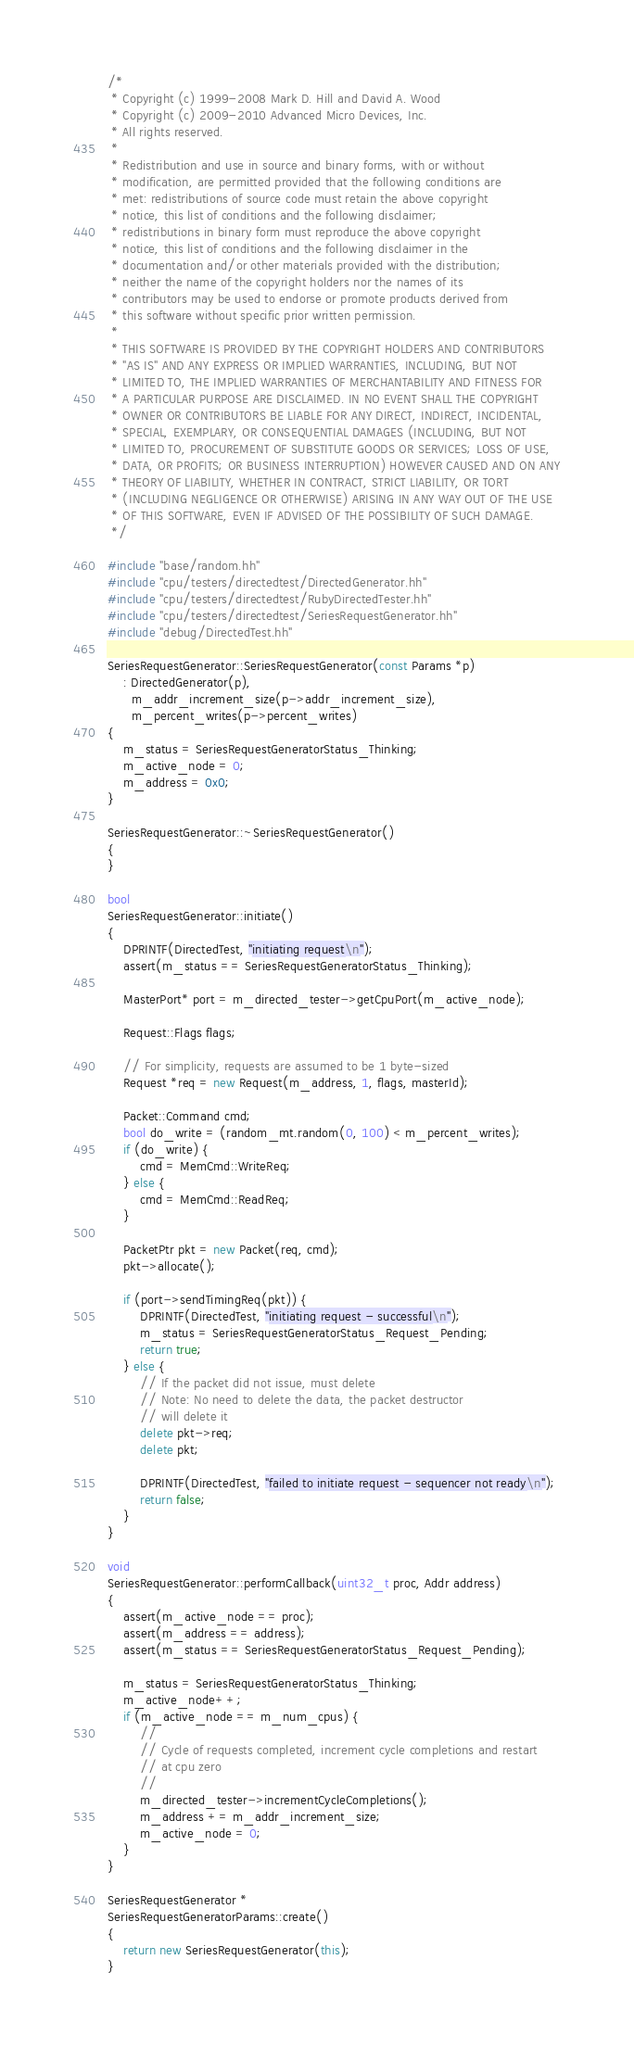<code> <loc_0><loc_0><loc_500><loc_500><_C++_>/*
 * Copyright (c) 1999-2008 Mark D. Hill and David A. Wood
 * Copyright (c) 2009-2010 Advanced Micro Devices, Inc.
 * All rights reserved.
 *
 * Redistribution and use in source and binary forms, with or without
 * modification, are permitted provided that the following conditions are
 * met: redistributions of source code must retain the above copyright
 * notice, this list of conditions and the following disclaimer;
 * redistributions in binary form must reproduce the above copyright
 * notice, this list of conditions and the following disclaimer in the
 * documentation and/or other materials provided with the distribution;
 * neither the name of the copyright holders nor the names of its
 * contributors may be used to endorse or promote products derived from
 * this software without specific prior written permission.
 *
 * THIS SOFTWARE IS PROVIDED BY THE COPYRIGHT HOLDERS AND CONTRIBUTORS
 * "AS IS" AND ANY EXPRESS OR IMPLIED WARRANTIES, INCLUDING, BUT NOT
 * LIMITED TO, THE IMPLIED WARRANTIES OF MERCHANTABILITY AND FITNESS FOR
 * A PARTICULAR PURPOSE ARE DISCLAIMED. IN NO EVENT SHALL THE COPYRIGHT
 * OWNER OR CONTRIBUTORS BE LIABLE FOR ANY DIRECT, INDIRECT, INCIDENTAL,
 * SPECIAL, EXEMPLARY, OR CONSEQUENTIAL DAMAGES (INCLUDING, BUT NOT
 * LIMITED TO, PROCUREMENT OF SUBSTITUTE GOODS OR SERVICES; LOSS OF USE,
 * DATA, OR PROFITS; OR BUSINESS INTERRUPTION) HOWEVER CAUSED AND ON ANY
 * THEORY OF LIABILITY, WHETHER IN CONTRACT, STRICT LIABILITY, OR TORT
 * (INCLUDING NEGLIGENCE OR OTHERWISE) ARISING IN ANY WAY OUT OF THE USE
 * OF THIS SOFTWARE, EVEN IF ADVISED OF THE POSSIBILITY OF SUCH DAMAGE.
 */

#include "base/random.hh"
#include "cpu/testers/directedtest/DirectedGenerator.hh"
#include "cpu/testers/directedtest/RubyDirectedTester.hh"
#include "cpu/testers/directedtest/SeriesRequestGenerator.hh"
#include "debug/DirectedTest.hh"

SeriesRequestGenerator::SeriesRequestGenerator(const Params *p)
    : DirectedGenerator(p),
      m_addr_increment_size(p->addr_increment_size),
      m_percent_writes(p->percent_writes)
{
    m_status = SeriesRequestGeneratorStatus_Thinking;
    m_active_node = 0;
    m_address = 0x0;
}

SeriesRequestGenerator::~SeriesRequestGenerator()
{
}

bool
SeriesRequestGenerator::initiate()
{
    DPRINTF(DirectedTest, "initiating request\n");
    assert(m_status == SeriesRequestGeneratorStatus_Thinking);

    MasterPort* port = m_directed_tester->getCpuPort(m_active_node);

    Request::Flags flags;

    // For simplicity, requests are assumed to be 1 byte-sized
    Request *req = new Request(m_address, 1, flags, masterId);

    Packet::Command cmd;
    bool do_write = (random_mt.random(0, 100) < m_percent_writes);
    if (do_write) {
        cmd = MemCmd::WriteReq;
    } else {
        cmd = MemCmd::ReadReq;
    }

    PacketPtr pkt = new Packet(req, cmd);
    pkt->allocate();

    if (port->sendTimingReq(pkt)) {
        DPRINTF(DirectedTest, "initiating request - successful\n");
        m_status = SeriesRequestGeneratorStatus_Request_Pending;
        return true;
    } else {
        // If the packet did not issue, must delete
        // Note: No need to delete the data, the packet destructor
        // will delete it
        delete pkt->req;
        delete pkt;

        DPRINTF(DirectedTest, "failed to initiate request - sequencer not ready\n");
        return false;
    }
}

void
SeriesRequestGenerator::performCallback(uint32_t proc, Addr address)
{
    assert(m_active_node == proc);
    assert(m_address == address);
    assert(m_status == SeriesRequestGeneratorStatus_Request_Pending);

    m_status = SeriesRequestGeneratorStatus_Thinking;
    m_active_node++;
    if (m_active_node == m_num_cpus) {
        //
        // Cycle of requests completed, increment cycle completions and restart
        // at cpu zero
        //
        m_directed_tester->incrementCycleCompletions();
        m_address += m_addr_increment_size;
        m_active_node = 0;
    }
}

SeriesRequestGenerator *
SeriesRequestGeneratorParams::create()
{
    return new SeriesRequestGenerator(this);
}
</code> 